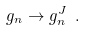Convert formula to latex. <formula><loc_0><loc_0><loc_500><loc_500>g _ { n } \rightarrow g _ { n } ^ { J } \ .</formula> 